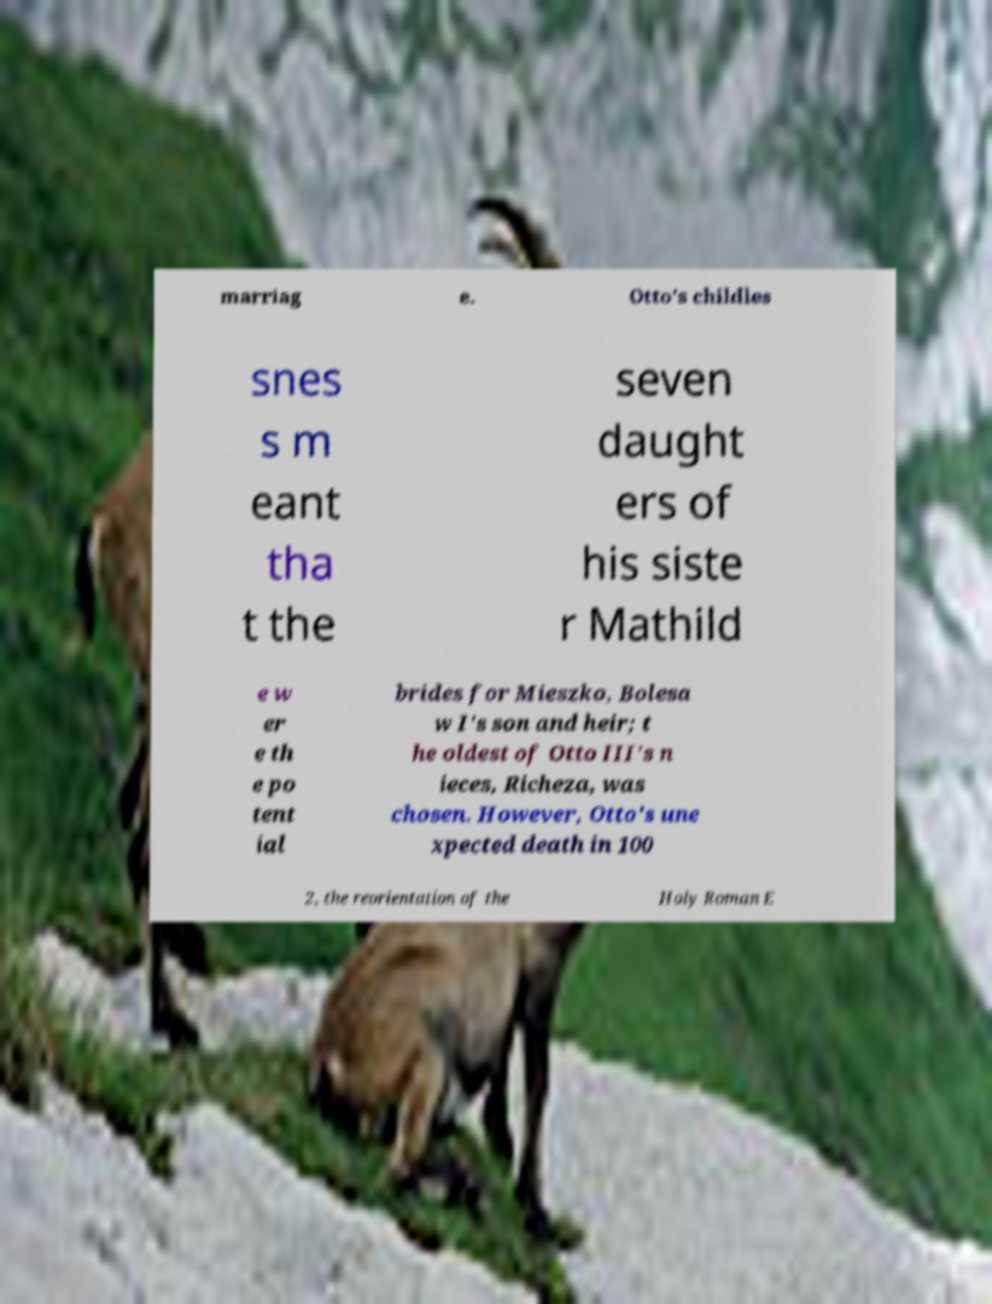Can you read and provide the text displayed in the image?This photo seems to have some interesting text. Can you extract and type it out for me? marriag e. Otto's childles snes s m eant tha t the seven daught ers of his siste r Mathild e w er e th e po tent ial brides for Mieszko, Bolesa w I's son and heir; t he oldest of Otto III's n ieces, Richeza, was chosen. However, Otto's une xpected death in 100 2, the reorientation of the Holy Roman E 